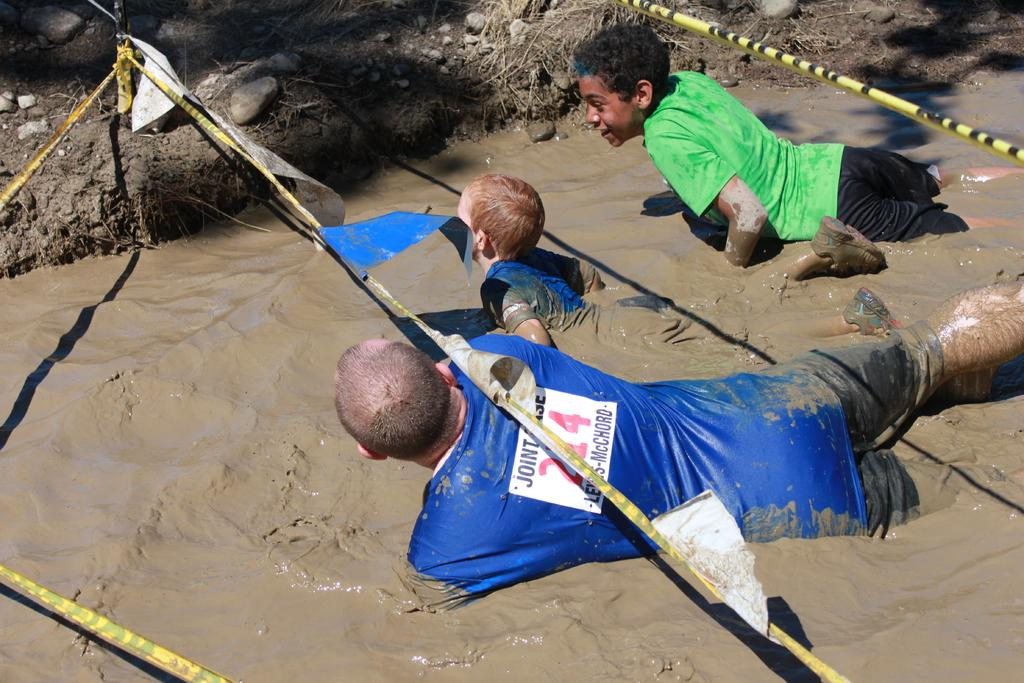Who or what is present in the image? There are people in the image. What is the condition of the people in the image? The people are in sludge. What can be seen in the background of the image? There are stones, plants, and ropes in the background of the image. What type of fairies can be seen flying around the people in the image? There are no fairies present in the image; it only features people in sludge and elements in the background. 